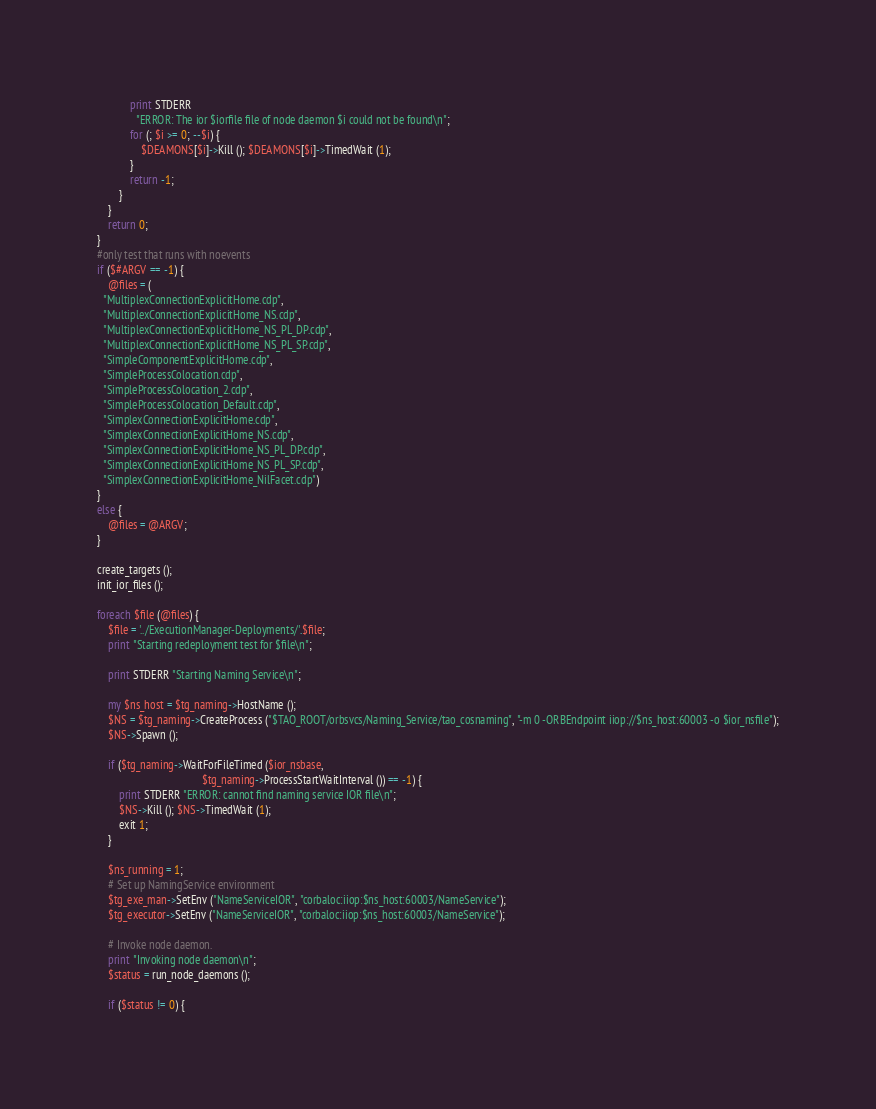Convert code to text. <code><loc_0><loc_0><loc_500><loc_500><_Perl_>            print STDERR
              "ERROR: The ior $iorfile file of node daemon $i could not be found\n";
            for (; $i >= 0; --$i) {
                $DEAMONS[$i]->Kill (); $DEAMONS[$i]->TimedWait (1);
            }
            return -1;
        }
    }
    return 0;
}
#only test that runs with noevents
if ($#ARGV == -1) {
    @files = (
  "MultiplexConnectionExplicitHome.cdp",
  "MultiplexConnectionExplicitHome_NS.cdp",
  "MultiplexConnectionExplicitHome_NS_PL_DP.cdp",
  "MultiplexConnectionExplicitHome_NS_PL_SP.cdp",
  "SimpleComponentExplicitHome.cdp",
  "SimpleProcessColocation.cdp",
  "SimpleProcessColocation_2.cdp",
  "SimpleProcessColocation_Default.cdp",
  "SimplexConnectionExplicitHome.cdp",
  "SimplexConnectionExplicitHome_NS.cdp",
  "SimplexConnectionExplicitHome_NS_PL_DP.cdp",
  "SimplexConnectionExplicitHome_NS_PL_SP.cdp",
  "SimplexConnectionExplicitHome_NilFacet.cdp")
}
else {
    @files = @ARGV;
}

create_targets ();
init_ior_files ();

foreach $file (@files) {
    $file = '../ExecutionManager-Deployments/'.$file;
    print "Starting redeployment test for $file\n";

    print STDERR "Starting Naming Service\n";

    my $ns_host = $tg_naming->HostName ();
    $NS = $tg_naming->CreateProcess ("$TAO_ROOT/orbsvcs/Naming_Service/tao_cosnaming", "-m 0 -ORBEndpoint iiop://$ns_host:60003 -o $ior_nsfile");
    $NS->Spawn ();

    if ($tg_naming->WaitForFileTimed ($ior_nsbase,
                                      $tg_naming->ProcessStartWaitInterval ()) == -1) {
        print STDERR "ERROR: cannot find naming service IOR file\n";
        $NS->Kill (); $NS->TimedWait (1);
        exit 1;
    }

    $ns_running = 1;
    # Set up NamingService environment
    $tg_exe_man->SetEnv ("NameServiceIOR", "corbaloc:iiop:$ns_host:60003/NameService");
    $tg_executor->SetEnv ("NameServiceIOR", "corbaloc:iiop:$ns_host:60003/NameService");

    # Invoke node daemon.
    print "Invoking node daemon\n";
    $status = run_node_daemons ();

    if ($status != 0) {</code> 